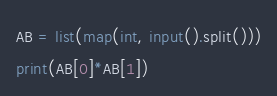Convert code to text. <code><loc_0><loc_0><loc_500><loc_500><_Python_>AB = list(map(int, input().split()))
print(AB[0]*AB[1])</code> 